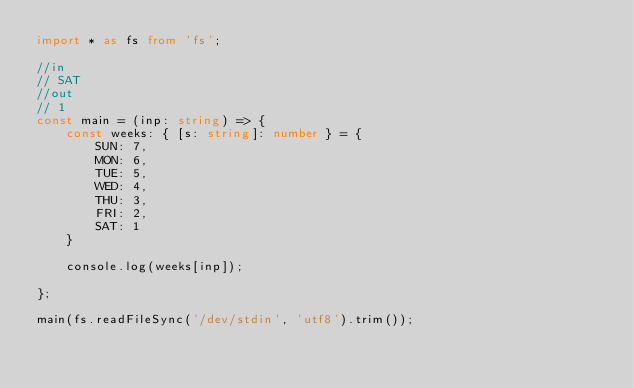<code> <loc_0><loc_0><loc_500><loc_500><_TypeScript_>import * as fs from 'fs';

//in
// SAT
//out
// 1
const main = (inp: string) => {
    const weeks: { [s: string]: number } = {
        SUN: 7,
        MON: 6,
        TUE: 5,
        WED: 4,
        THU: 3,
        FRI: 2,
        SAT: 1
    }

    console.log(weeks[inp]);

};

main(fs.readFileSync('/dev/stdin', 'utf8').trim());</code> 